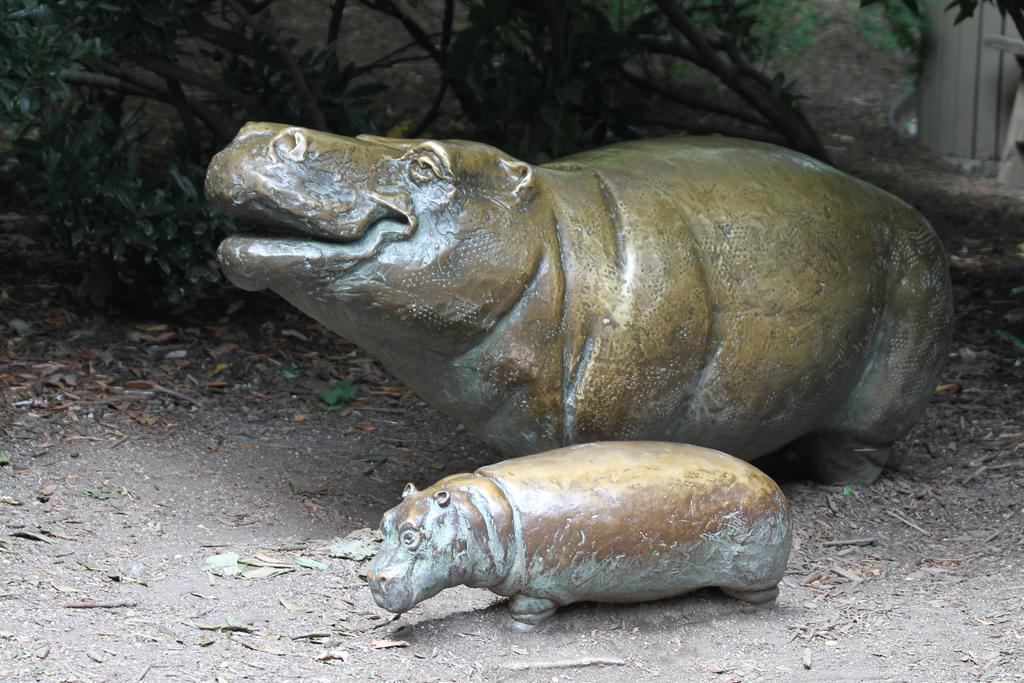What types of living organisms are depicted in the image? There are depictions of animals in the image. What can be seen in the background of the image? There are plants in the background of the image. What type of surface is visible at the bottom of the image? There is soil visible at the bottom of the image. What type of frame surrounds the animals in the image? There is no frame surrounding the animals in the image; it is a flat representation of the animals and plants. 